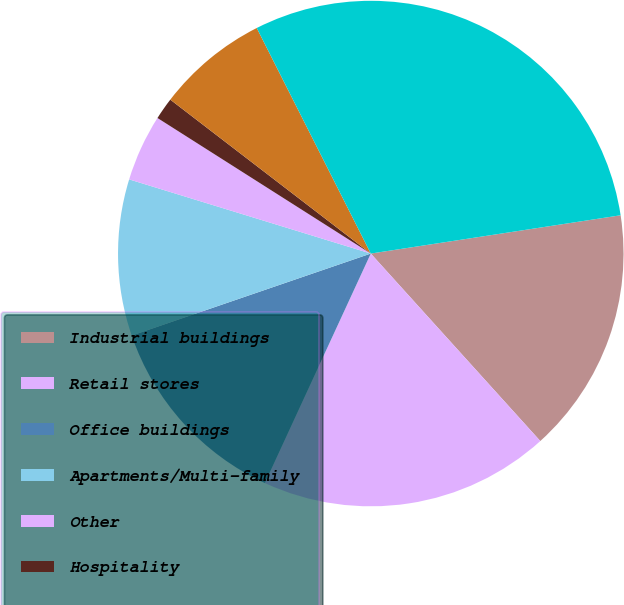Convert chart. <chart><loc_0><loc_0><loc_500><loc_500><pie_chart><fcel>Industrial buildings<fcel>Retail stores<fcel>Office buildings<fcel>Apartments/Multi-family<fcel>Other<fcel>Hospitality<fcel>Agricultural properties<fcel>Total commercial and<nl><fcel>15.72%<fcel>18.58%<fcel>12.86%<fcel>10.0%<fcel>4.27%<fcel>1.41%<fcel>7.13%<fcel>30.03%<nl></chart> 